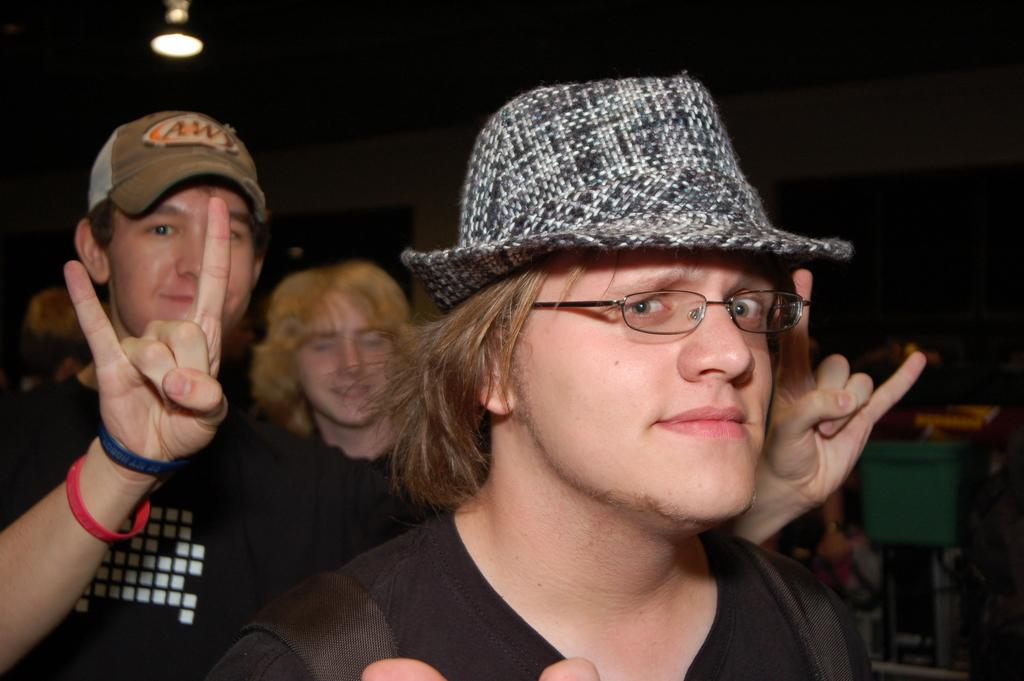What is the main subject of the image? There is a man standing in the image. Can you describe the man's appearance? The man is wearing glasses and a black t-shirt. What can be seen in the background of the image? There is a group of people standing in the background. What is the source of light in the image? There is a light visible in the image. What type of noise is the creator making in the image? There is no creator or noise present in the image; it features a man standing and a group of people in the background. 